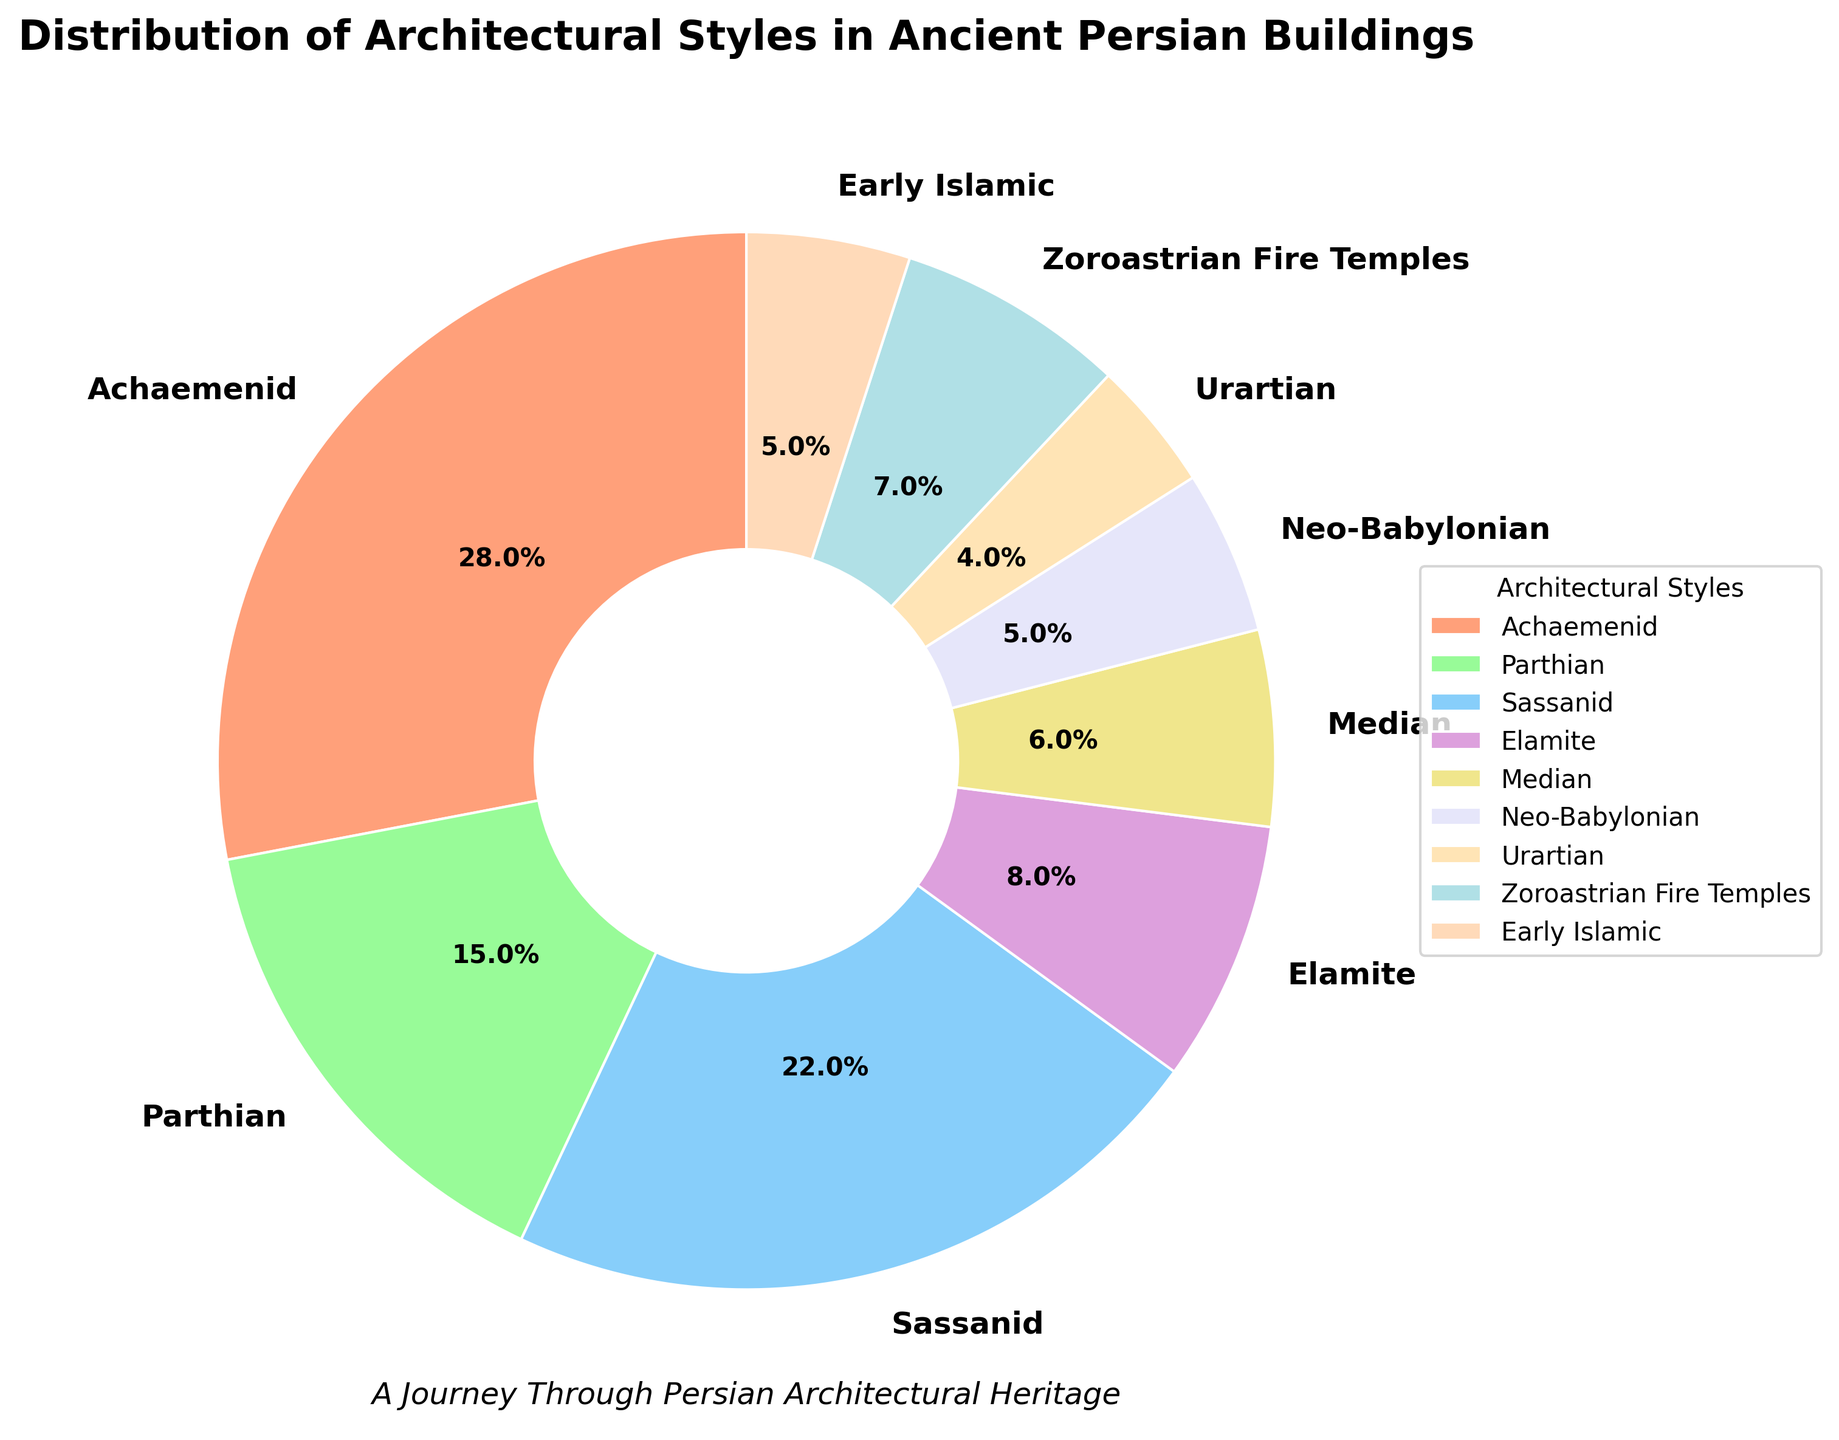What is the most prevalent architectural style according to the pie chart? The most prevalent architectural style is the one with the highest percentage. According to the chart, Achaemenid has the highest percentage at 28%.
Answer: Achaemenid Which two architectural styles have a combined percentage of exactly 10%? To find two architectural styles that add up to 10%, we observe the chart and identify that Elamite (8%) and Median (6%) are the closest but surpass 10%. Recognizing Neo-Babylonian (5%) and Early Islamic (5%) add up perfectly to 10%.
Answer: Neo-Babylonian and Early Islamic How does the percentage of Sassanid compare to the percentage of Parthian? From the chart, Sassanid is represented with 22% while Parthian holds 15%. This means Sassanid has a higher percentage compared to Parthian.
Answer: Sassanid is higher than Parthian What color is used to represent the Zoroastrian Fire Temples? The chart uses different colors for different styles. The Zoroastrian Fire Temples, which have a 7% share, are visually represented by the color that matches the section labeled as Zoroastrian Fire Temples. In this case, it's blue.
Answer: Blue What is the total percentage of all styles except Achaemenid? The total percentage of all styles except Achaemenid (28%) is derived by subtracting 28 from 100. Thus, the required sum is 100 - 28 = 72%.
Answer: 72% What is the least common architectural style, and what percentage does it hold? To determine the least common style, we find the one with the lowest percentage. The chart shows that Urartian has the smallest share at 4%.
Answer: Urartian at 4% How does the combined percentage of Parthian and Zoroastrian Fire Temples compare to Achaemenid? We sum up the percentages of Parthian (15%) and Zoroastrian Fire Temples (7%) which gives 15 + 7 = 22%. Then compare with Achaemenid, which is 28%. So, 22% is less than 28%.
Answer: Less than Achaemenid What is the difference in percentage between the most and least common architectural styles? The most common style is Achaemenid (28%) and the least common is Urartian (4%). The difference is calculated as 28 - 4 = 24%.
Answer: 24% Which styles have a percentage within 5%-10%, inclusive? From the pie chart, the styles within 5%-10% are Elamite (8%), Median (6%), Neo-Babylonian (5%), and Early Islamic (5%).
Answer: Elamite, Median, Neo-Babylonian, and Early Islamic 